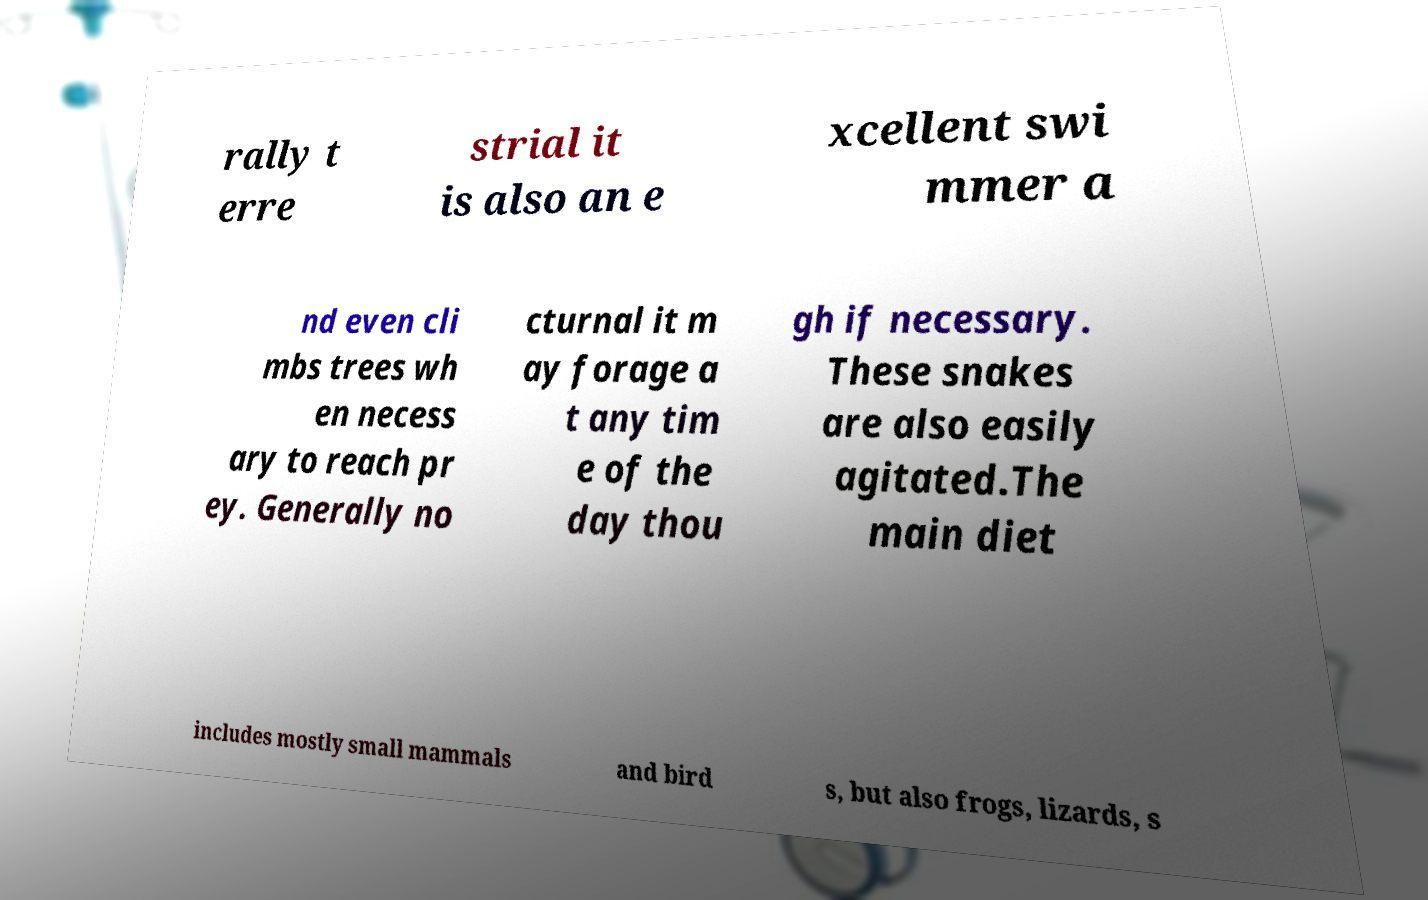Please read and relay the text visible in this image. What does it say? rally t erre strial it is also an e xcellent swi mmer a nd even cli mbs trees wh en necess ary to reach pr ey. Generally no cturnal it m ay forage a t any tim e of the day thou gh if necessary. These snakes are also easily agitated.The main diet includes mostly small mammals and bird s, but also frogs, lizards, s 